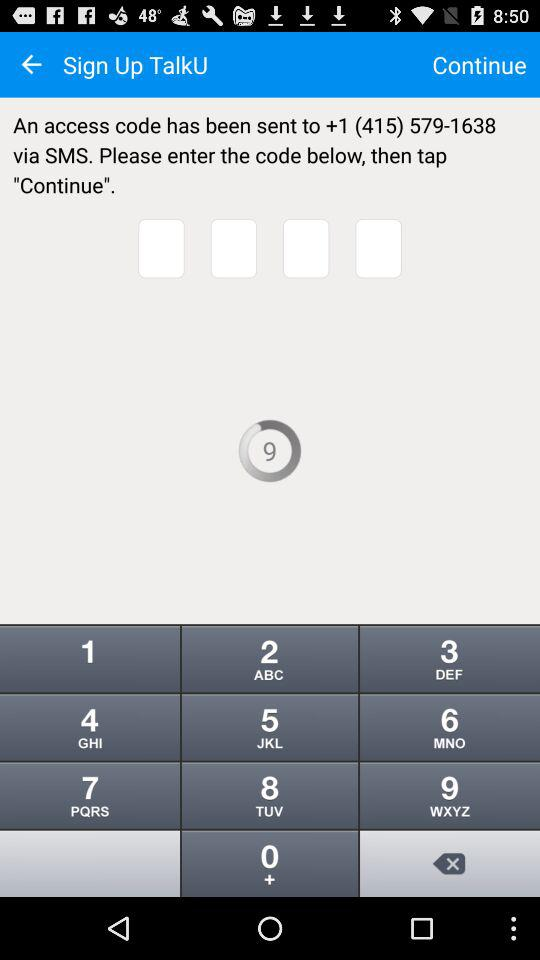How many digits are in the access code?
Answer the question using a single word or phrase. 4 